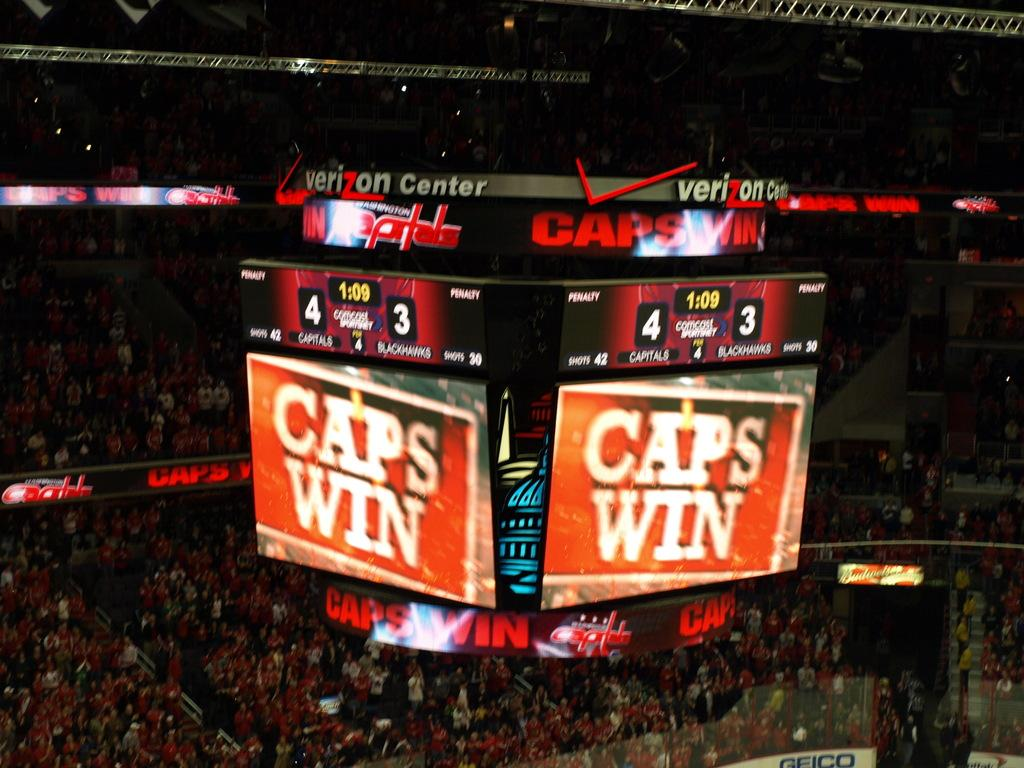Provide a one-sentence caption for the provided image. A large tv screen that says CAPS WIN in big letters. 